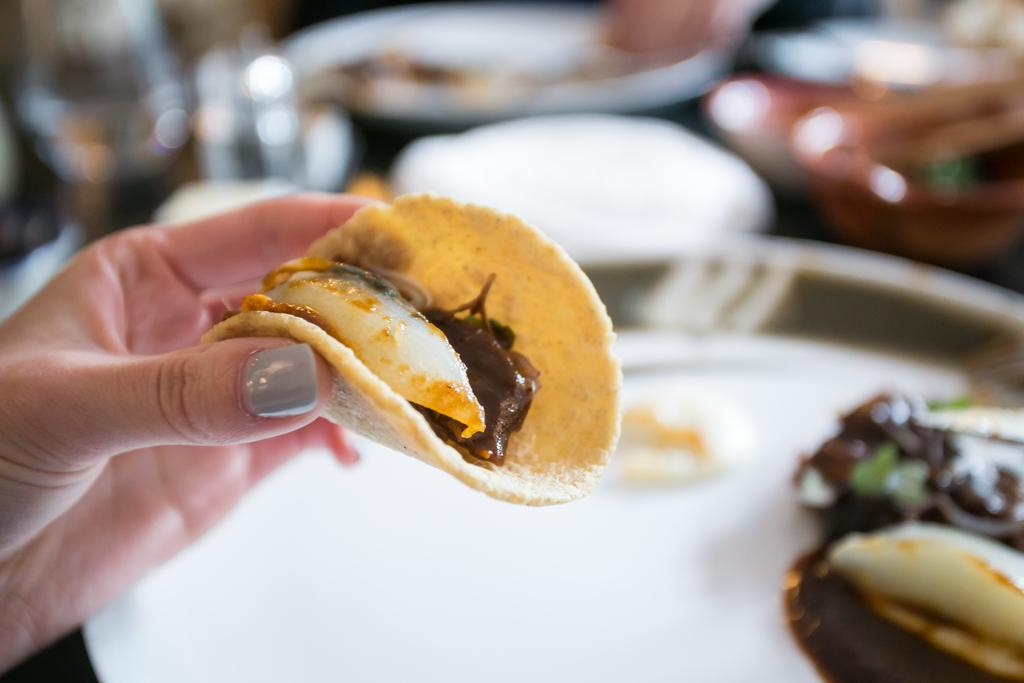What types of objects are present on the table in the image? There are plates and dishes in the image. Can you describe the human presence in the image? There is a human hand on the left side of the image. What type of crate is being used to store the love in the image? There is no crate or love present in the image; it only features plates, dishes, and a human hand. 